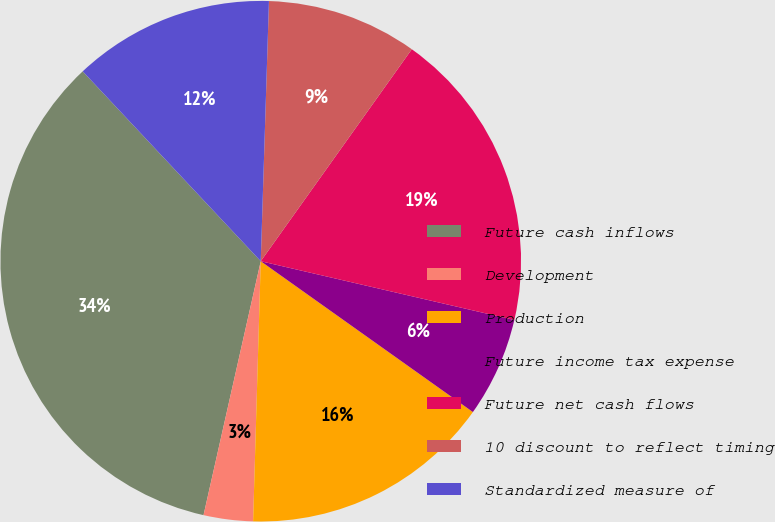Convert chart to OTSL. <chart><loc_0><loc_0><loc_500><loc_500><pie_chart><fcel>Future cash inflows<fcel>Development<fcel>Production<fcel>Future income tax expense<fcel>Future net cash flows<fcel>10 discount to reflect timing<fcel>Standardized measure of<nl><fcel>34.48%<fcel>3.06%<fcel>15.63%<fcel>6.21%<fcel>18.77%<fcel>9.35%<fcel>12.49%<nl></chart> 